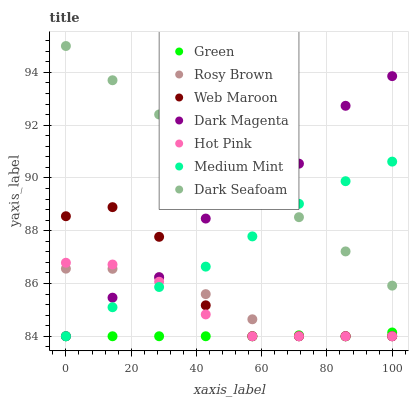Does Green have the minimum area under the curve?
Answer yes or no. Yes. Does Dark Seafoam have the maximum area under the curve?
Answer yes or no. Yes. Does Hot Pink have the minimum area under the curve?
Answer yes or no. No. Does Hot Pink have the maximum area under the curve?
Answer yes or no. No. Is Dark Seafoam the smoothest?
Answer yes or no. Yes. Is Dark Magenta the roughest?
Answer yes or no. Yes. Is Hot Pink the smoothest?
Answer yes or no. No. Is Hot Pink the roughest?
Answer yes or no. No. Does Medium Mint have the lowest value?
Answer yes or no. Yes. Does Dark Seafoam have the lowest value?
Answer yes or no. No. Does Dark Seafoam have the highest value?
Answer yes or no. Yes. Does Hot Pink have the highest value?
Answer yes or no. No. Is Green less than Dark Seafoam?
Answer yes or no. Yes. Is Dark Seafoam greater than Green?
Answer yes or no. Yes. Does Web Maroon intersect Rosy Brown?
Answer yes or no. Yes. Is Web Maroon less than Rosy Brown?
Answer yes or no. No. Is Web Maroon greater than Rosy Brown?
Answer yes or no. No. Does Green intersect Dark Seafoam?
Answer yes or no. No. 